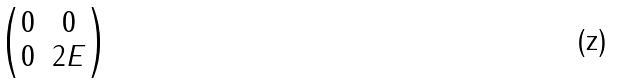<formula> <loc_0><loc_0><loc_500><loc_500>\begin{pmatrix} 0 & 0 \\ 0 & 2 E \end{pmatrix}</formula> 